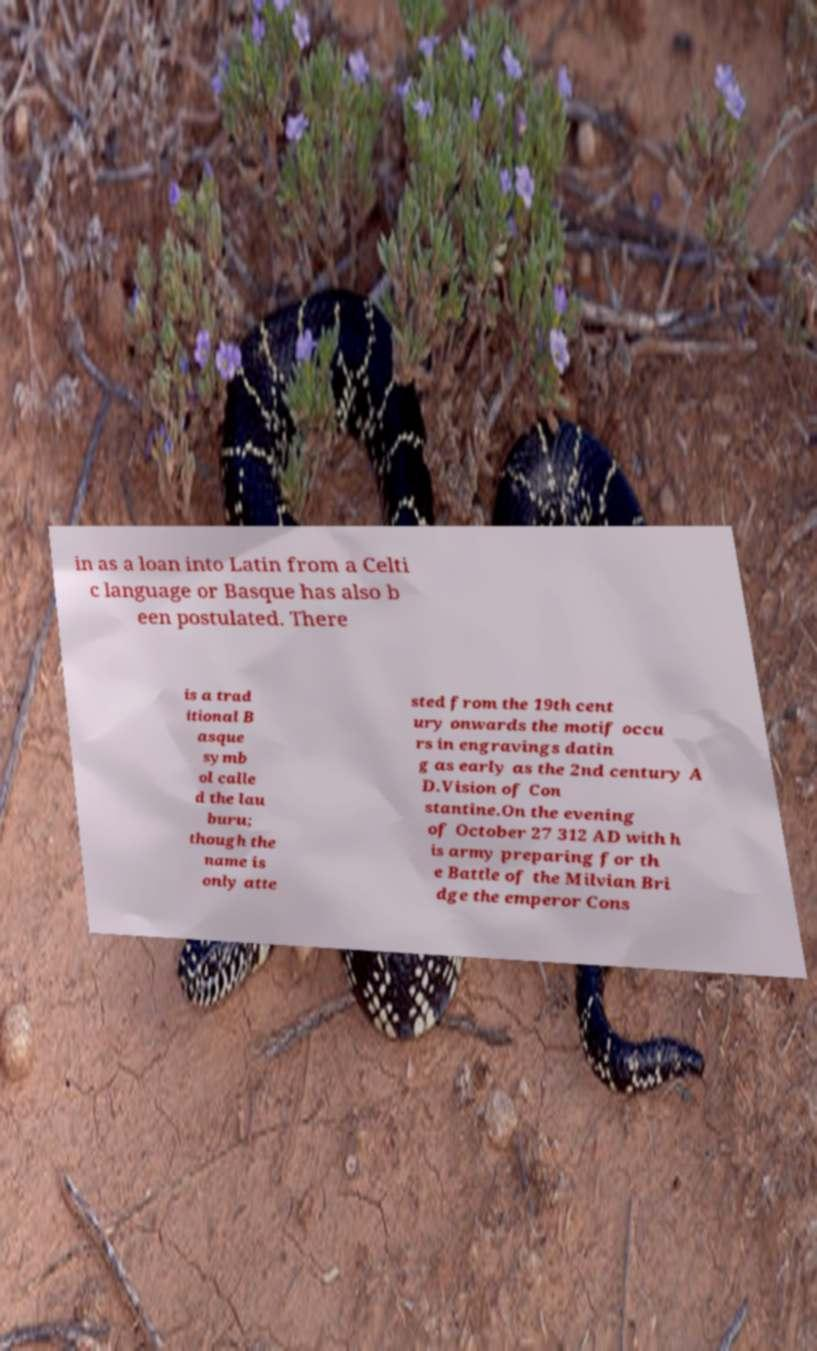Can you read and provide the text displayed in the image?This photo seems to have some interesting text. Can you extract and type it out for me? in as a loan into Latin from a Celti c language or Basque has also b een postulated. There is a trad itional B asque symb ol calle d the lau buru; though the name is only atte sted from the 19th cent ury onwards the motif occu rs in engravings datin g as early as the 2nd century A D.Vision of Con stantine.On the evening of October 27 312 AD with h is army preparing for th e Battle of the Milvian Bri dge the emperor Cons 